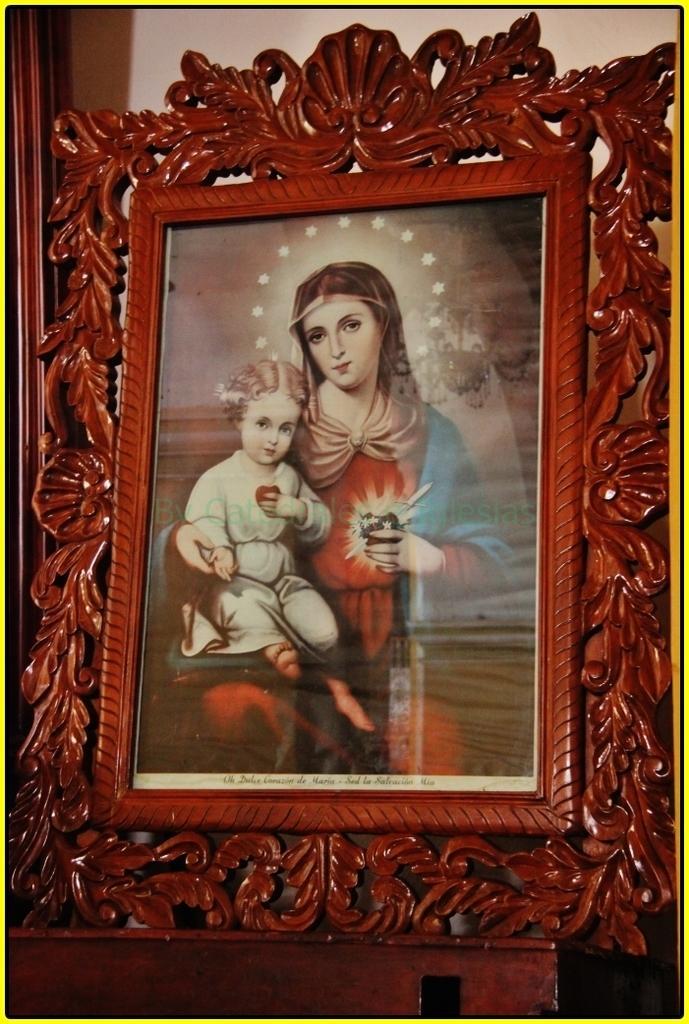Can you describe this image briefly? This image is a photo frame of Jesus with his mother and the frame is placed on the wooden surface. The image has borders. 